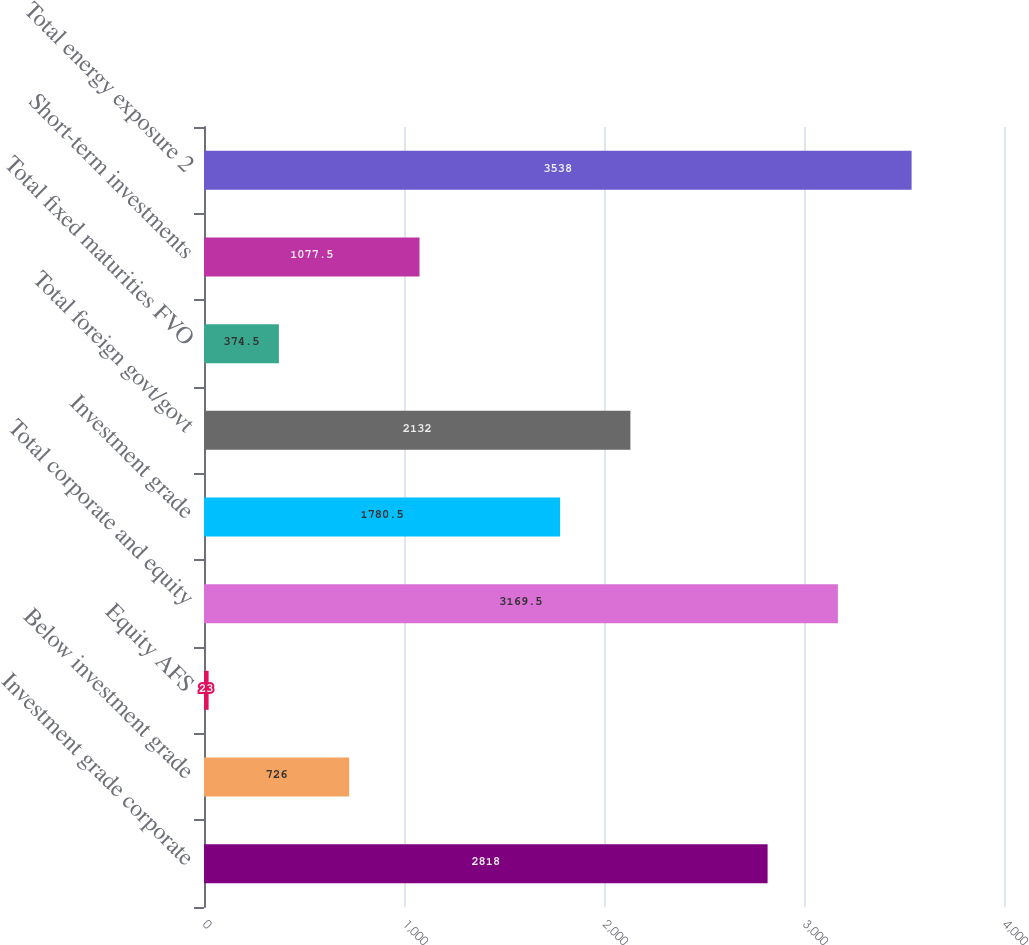Convert chart to OTSL. <chart><loc_0><loc_0><loc_500><loc_500><bar_chart><fcel>Investment grade corporate<fcel>Below investment grade<fcel>Equity AFS<fcel>Total corporate and equity<fcel>Investment grade<fcel>Total foreign govt/govt<fcel>Total fixed maturities FVO<fcel>Short-term investments<fcel>Total energy exposure 2<nl><fcel>2818<fcel>726<fcel>23<fcel>3169.5<fcel>1780.5<fcel>2132<fcel>374.5<fcel>1077.5<fcel>3538<nl></chart> 